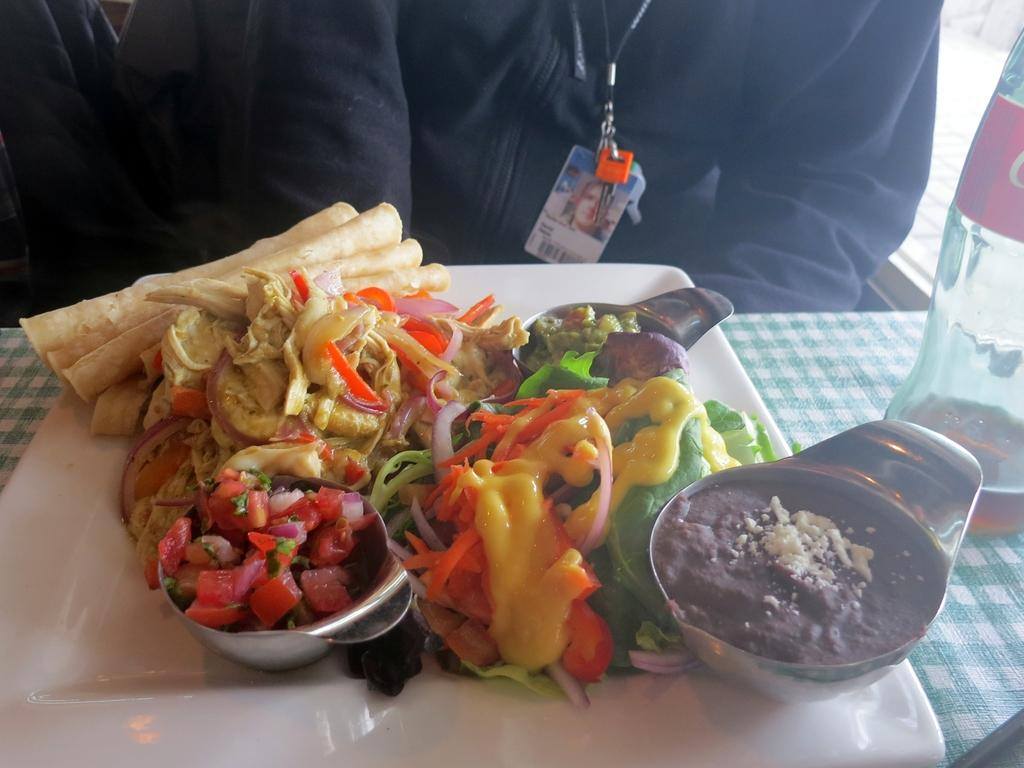What is the person in the image doing? The person is sitting in the image. Where is the person sitting in relation to the table? The person is sitting in front of a table. What can be found on the table in the image? There are food items and a bottle on the table. What type of disease is the person suffering from in the image? There is no indication of any disease in the image; the person is simply sitting in front of a table. 